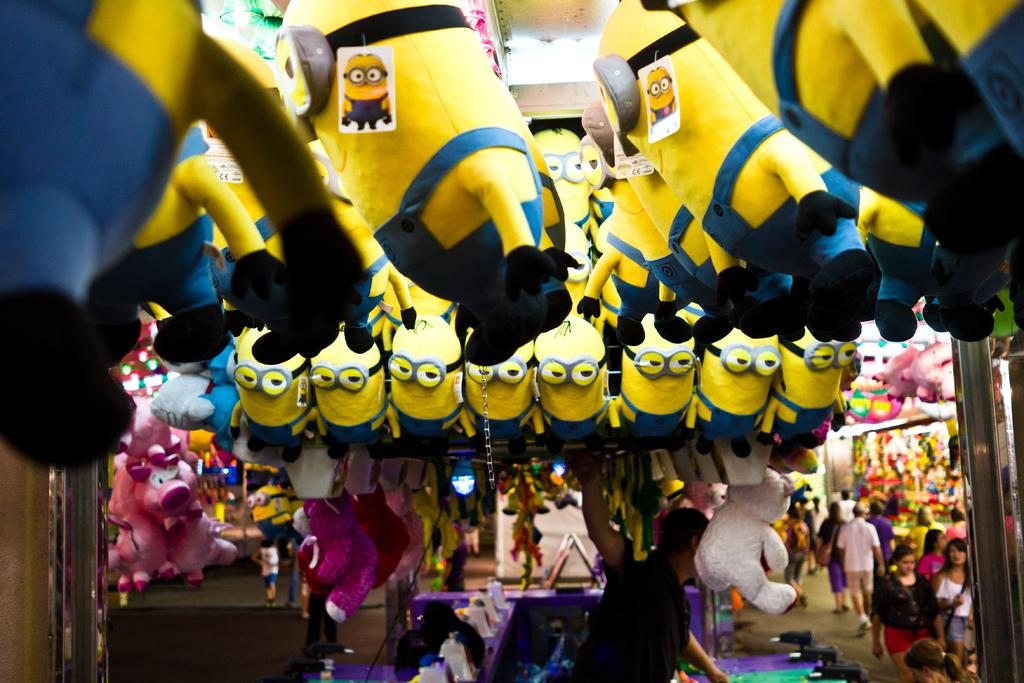What type of toys are present in the image? There are soft toys in the image. Where are the people located in the image? The people are on the right side of the image. What else can be seen on the right side of the image besides the people? There are other objects on the right side of the image. What is the name of the brother of the soft toy in the image? There is no brother mentioned or depicted for the soft toys in the image. 